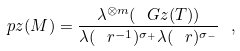<formula> <loc_0><loc_0><loc_500><loc_500>\ p z ( M ) = \frac { \lambda ^ { \otimes m } ( \ G z ( T ) ) } { \lambda ( \ r ^ { - 1 } ) ^ { \sigma _ { + } } \lambda ( \ r ) ^ { \sigma _ { - } } } \ ,</formula> 